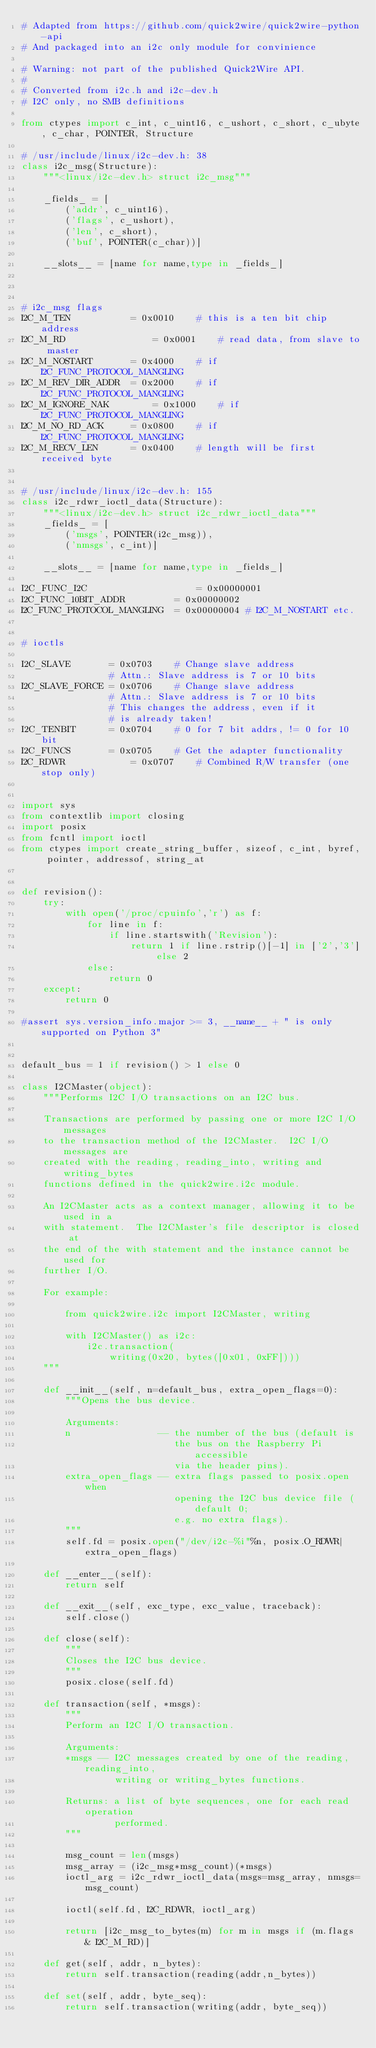<code> <loc_0><loc_0><loc_500><loc_500><_Python_># Adapted from https://github.com/quick2wire/quick2wire-python-api
# And packaged into an i2c only module for convinience

# Warning: not part of the published Quick2Wire API.
#
# Converted from i2c.h and i2c-dev.h
# I2C only, no SMB definitions

from ctypes import c_int, c_uint16, c_ushort, c_short, c_ubyte, c_char, POINTER, Structure

# /usr/include/linux/i2c-dev.h: 38
class i2c_msg(Structure):
    """<linux/i2c-dev.h> struct i2c_msg"""
    
    _fields_ = [
        ('addr', c_uint16),
        ('flags', c_ushort),
        ('len', c_short),
        ('buf', POINTER(c_char))]
    
    __slots__ = [name for name,type in _fields_]



# i2c_msg flags
I2C_M_TEN			= 0x0010	# this is a ten bit chip address
I2C_M_RD				= 0x0001	# read data, from slave to master
I2C_M_NOSTART		= 0x4000	# if I2C_FUNC_PROTOCOL_MANGLING
I2C_M_REV_DIR_ADDR	= 0x2000	# if I2C_FUNC_PROTOCOL_MANGLING
I2C_M_IGNORE_NAK		= 0x1000	# if I2C_FUNC_PROTOCOL_MANGLING
I2C_M_NO_RD_ACK		= 0x0800	# if I2C_FUNC_PROTOCOL_MANGLING
I2C_M_RECV_LEN		= 0x0400	# length will be first received byte


# /usr/include/linux/i2c-dev.h: 155
class i2c_rdwr_ioctl_data(Structure):
    """<linux/i2c-dev.h> struct i2c_rdwr_ioctl_data"""
    _fields_ = [
        ('msgs', POINTER(i2c_msg)),
        ('nmsgs', c_int)]

    __slots__ = [name for name,type in _fields_]

I2C_FUNC_I2C					= 0x00000001
I2C_FUNC_10BIT_ADDR			= 0x00000002
I2C_FUNC_PROTOCOL_MANGLING	= 0x00000004 # I2C_M_NOSTART etc.


# ioctls

I2C_SLAVE		= 0x0703	# Change slave address			
				# Attn.: Slave address is 7 or 10 bits  
I2C_SLAVE_FORCE	= 0x0706	# Change slave address			
				# Attn.: Slave address is 7 or 10 bits  
				# This changes the address, even if it  
				# is already taken!			
I2C_TENBIT		= 0x0704	# 0 for 7 bit addrs, != 0 for 10 bit	
I2C_FUNCS		= 0x0705	# Get the adapter functionality         
I2C_RDWR			= 0x0707	# Combined R/W transfer (one stop only) 


import sys
from contextlib import closing
import posix
from fcntl import ioctl
from ctypes import create_string_buffer, sizeof, c_int, byref, pointer, addressof, string_at


def revision():
    try:
        with open('/proc/cpuinfo','r') as f:
            for line in f:
                if line.startswith('Revision'):
                    return 1 if line.rstrip()[-1] in ['2','3'] else 2
            else:
                return 0
    except:
        return 0

#assert sys.version_info.major >= 3, __name__ + " is only supported on Python 3"


default_bus = 1 if revision() > 1 else 0

class I2CMaster(object):
    """Performs I2C I/O transactions on an I2C bus.
    
    Transactions are performed by passing one or more I2C I/O messages
    to the transaction method of the I2CMaster.  I2C I/O messages are
    created with the reading, reading_into, writing and writing_bytes
    functions defined in the quick2wire.i2c module.
    
    An I2CMaster acts as a context manager, allowing it to be used in a
    with statement.  The I2CMaster's file descriptor is closed at
    the end of the with statement and the instance cannot be used for
    further I/O.
    
    For example:
    
        from quick2wire.i2c import I2CMaster, writing
        
        with I2CMaster() as i2c:
            i2c.transaction(
                writing(0x20, bytes([0x01, 0xFF])))
    """
    
    def __init__(self, n=default_bus, extra_open_flags=0):
        """Opens the bus device.
        
        Arguments:
        n                -- the number of the bus (default is
                            the bus on the Raspberry Pi accessible
                            via the header pins).
        extra_open_flags -- extra flags passed to posix.open when 
                            opening the I2C bus device file (default 0; 
                            e.g. no extra flags).
        """
        self.fd = posix.open("/dev/i2c-%i"%n, posix.O_RDWR|extra_open_flags)
    
    def __enter__(self):
        return self
    
    def __exit__(self, exc_type, exc_value, traceback):
        self.close()
    
    def close(self):
        """
        Closes the I2C bus device.
        """
        posix.close(self.fd)
    
    def transaction(self, *msgs):
        """
        Perform an I2C I/O transaction.

        Arguments:
        *msgs -- I2C messages created by one of the reading, reading_into,
                 writing or writing_bytes functions.
        
        Returns: a list of byte sequences, one for each read operation 
                 performed.
        """
        
        msg_count = len(msgs)
        msg_array = (i2c_msg*msg_count)(*msgs)
        ioctl_arg = i2c_rdwr_ioctl_data(msgs=msg_array, nmsgs=msg_count)
        
        ioctl(self.fd, I2C_RDWR, ioctl_arg)
        
        return [i2c_msg_to_bytes(m) for m in msgs if (m.flags & I2C_M_RD)]
	
    def get(self, addr, n_bytes):
        return self.transaction(reading(addr,n_bytes))

    def set(self, addr, byte_seq):
        return self.transaction(writing(addr, byte_seq))
</code> 